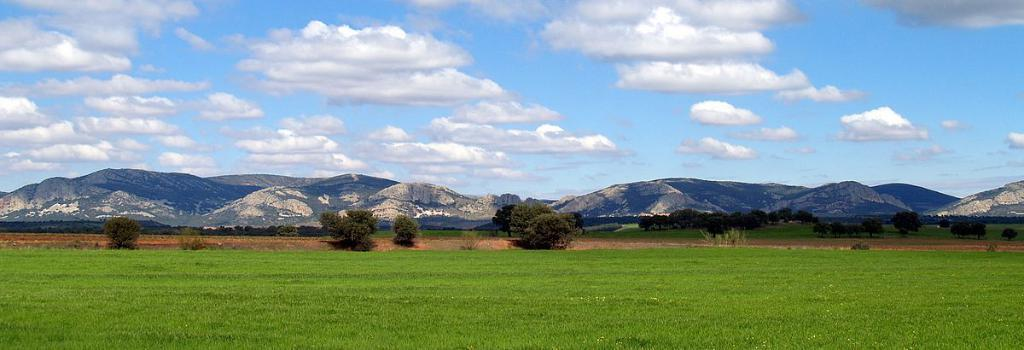What type of terrain is visible in the image? There is a grass field in the image. Are there any other natural elements present in the image? Yes, there is a tree and mountains visible in the image. What is visible in the sky in the image? There are clouds in the sky in the image. What type of word can be seen on the lamp in the image? There is no lamp present in the image, so it is not possible to answer that question. 